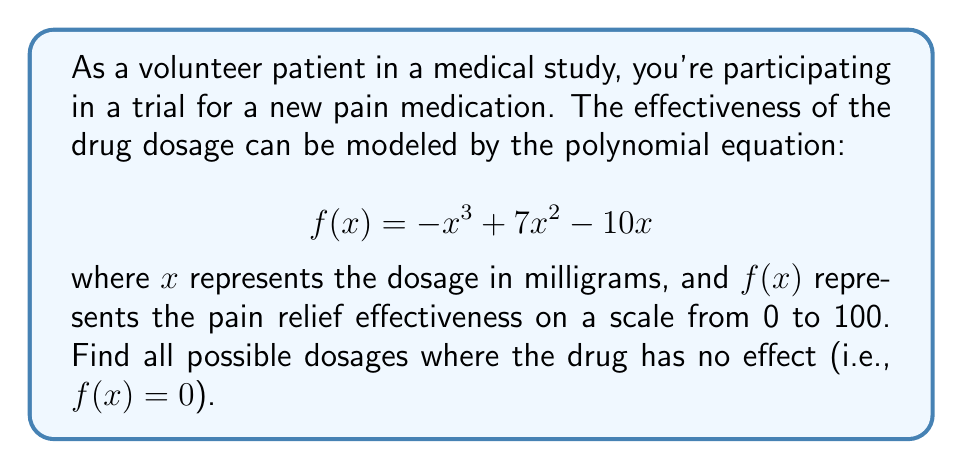Help me with this question. To find the roots of the polynomial equation, we need to solve:

$$-x^3 + 7x^2 - 10x = 0$$

1) First, factor out the common factor $x$:
   $$x(-x^2 + 7x - 10) = 0$$

2) Using the zero product property, we can split this into two equations:
   $$x = 0$$ or $$-x^2 + 7x - 10 = 0$$

3) We already have one root: $x = 0$

4) For the quadratic equation $-x^2 + 7x - 10 = 0$, we can solve using the quadratic formula:
   $$x = \frac{-b \pm \sqrt{b^2 - 4ac}}{2a}$$
   where $a = -1$, $b = 7$, and $c = -10$

5) Substituting these values:
   $$x = \frac{-7 \pm \sqrt{7^2 - 4(-1)(-10)}}{2(-1)}$$
   $$x = \frac{-7 \pm \sqrt{49 - 40}}{-2}$$
   $$x = \frac{-7 \pm \sqrt{9}}{-2}$$
   $$x = \frac{-7 \pm 3}{-2}$$

6) This gives us two more roots:
   $$x = \frac{-7 + 3}{-2} = 2$$ and $$x = \frac{-7 - 3}{-2} = 5$$

Therefore, the roots of the equation are 0, 2, and 5 mg.
Answer: The drug has no effect at dosages of 0 mg, 2 mg, and 5 mg. 